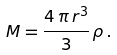Convert formula to latex. <formula><loc_0><loc_0><loc_500><loc_500>M = \frac { 4 \, \pi \, r ^ { 3 } } { 3 } \, \rho \, .</formula> 